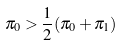<formula> <loc_0><loc_0><loc_500><loc_500>\pi _ { 0 } > \frac { 1 } { 2 } ( \pi _ { 0 } + \pi _ { 1 } )</formula> 